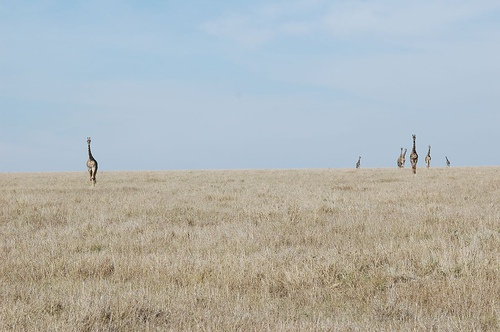Describe the objects in this image and their specific colors. I can see giraffe in lightblue, darkgray, black, and gray tones, giraffe in lightblue, gray, darkgray, and black tones, giraffe in lightblue, darkgray, gray, lightgray, and tan tones, giraffe in lightblue, darkgray, gray, and black tones, and giraffe in lightblue, darkgray, and gray tones in this image. 